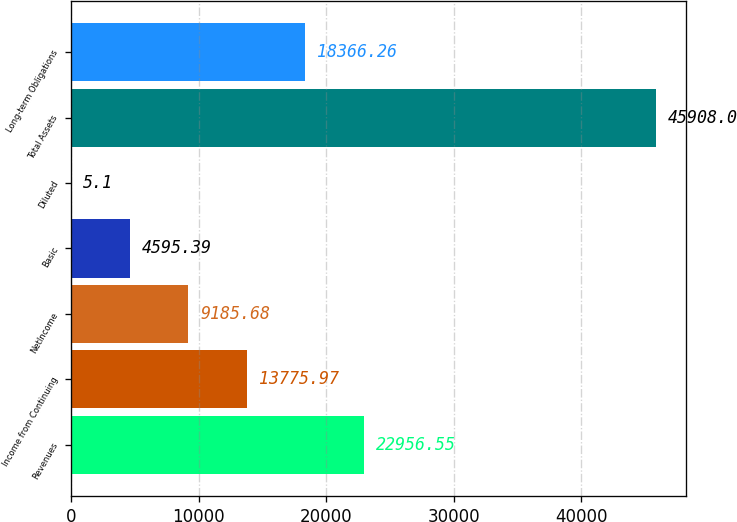Convert chart. <chart><loc_0><loc_0><loc_500><loc_500><bar_chart><fcel>Revenues<fcel>Income from Continuing<fcel>NetIncome<fcel>Basic<fcel>Diluted<fcel>Total Assets<fcel>Long-term Obligations<nl><fcel>22956.5<fcel>13776<fcel>9185.68<fcel>4595.39<fcel>5.1<fcel>45908<fcel>18366.3<nl></chart> 